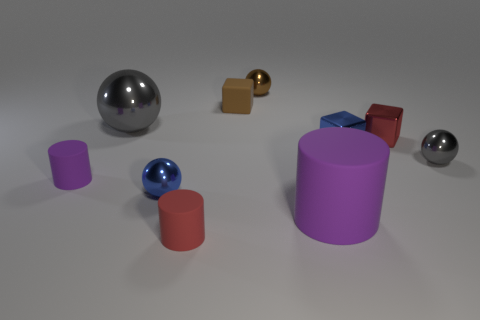Do the metal object in front of the tiny gray sphere and the large metallic sphere have the same color?
Your answer should be very brief. No. What number of brown things are tiny shiny objects or small rubber cylinders?
Provide a short and direct response. 1. Is there any other thing that is made of the same material as the small red block?
Give a very brief answer. Yes. Does the block to the left of the big purple cylinder have the same material as the large cylinder?
Make the answer very short. Yes. How many objects are tiny balls or small cylinders in front of the tiny purple thing?
Keep it short and to the point. 4. There is a big thing in front of the blue shiny thing that is on the right side of the big matte cylinder; what number of tiny cylinders are behind it?
Your answer should be compact. 1. There is a tiny red thing that is behind the tiny purple rubber cylinder; is it the same shape as the large purple thing?
Provide a succinct answer. No. There is a red thing that is to the left of the tiny brown metal thing; are there any large purple rubber objects in front of it?
Keep it short and to the point. No. What number of objects are there?
Your answer should be compact. 10. There is a shiny sphere that is on the right side of the small blue shiny sphere and in front of the brown ball; what is its color?
Your response must be concise. Gray. 